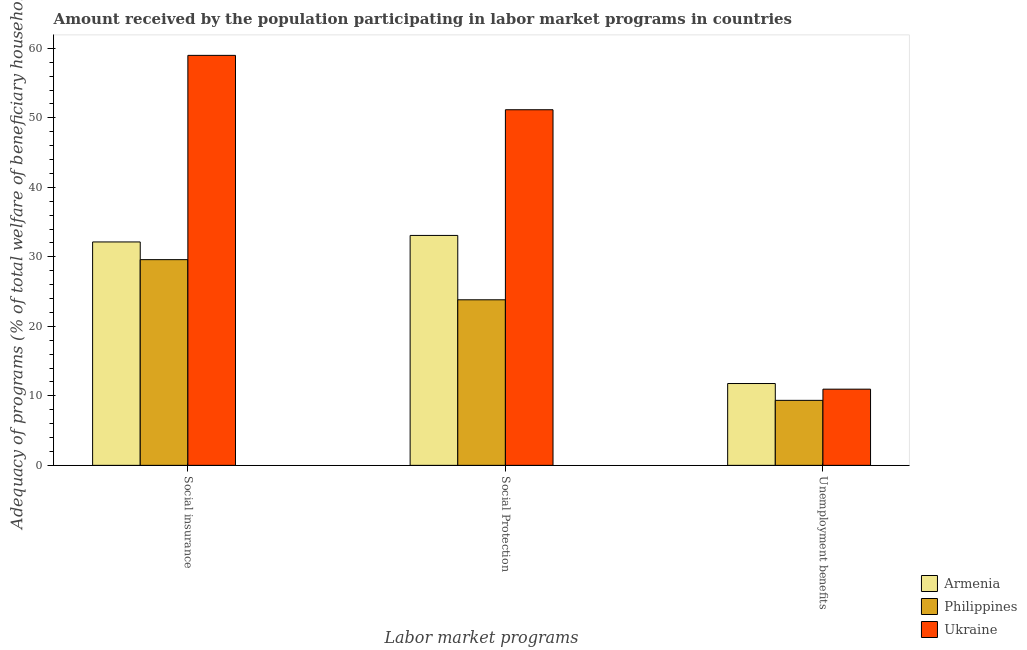How many different coloured bars are there?
Offer a terse response. 3. How many groups of bars are there?
Provide a succinct answer. 3. Are the number of bars per tick equal to the number of legend labels?
Keep it short and to the point. Yes. What is the label of the 3rd group of bars from the left?
Ensure brevity in your answer.  Unemployment benefits. What is the amount received by the population participating in unemployment benefits programs in Philippines?
Give a very brief answer. 9.35. Across all countries, what is the maximum amount received by the population participating in unemployment benefits programs?
Your answer should be very brief. 11.77. Across all countries, what is the minimum amount received by the population participating in unemployment benefits programs?
Your answer should be very brief. 9.35. In which country was the amount received by the population participating in social protection programs maximum?
Provide a succinct answer. Ukraine. In which country was the amount received by the population participating in social protection programs minimum?
Your answer should be very brief. Philippines. What is the total amount received by the population participating in social protection programs in the graph?
Provide a short and direct response. 108.08. What is the difference between the amount received by the population participating in social insurance programs in Armenia and that in Philippines?
Make the answer very short. 2.55. What is the difference between the amount received by the population participating in social protection programs in Armenia and the amount received by the population participating in unemployment benefits programs in Philippines?
Make the answer very short. 23.73. What is the average amount received by the population participating in social protection programs per country?
Provide a short and direct response. 36.03. What is the difference between the amount received by the population participating in social insurance programs and amount received by the population participating in social protection programs in Armenia?
Provide a succinct answer. -0.94. In how many countries, is the amount received by the population participating in unemployment benefits programs greater than 12 %?
Provide a short and direct response. 0. What is the ratio of the amount received by the population participating in unemployment benefits programs in Philippines to that in Armenia?
Your answer should be very brief. 0.79. Is the difference between the amount received by the population participating in social insurance programs in Philippines and Ukraine greater than the difference between the amount received by the population participating in unemployment benefits programs in Philippines and Ukraine?
Provide a succinct answer. No. What is the difference between the highest and the second highest amount received by the population participating in social protection programs?
Provide a succinct answer. 18.09. What is the difference between the highest and the lowest amount received by the population participating in social insurance programs?
Provide a succinct answer. 29.4. In how many countries, is the amount received by the population participating in social protection programs greater than the average amount received by the population participating in social protection programs taken over all countries?
Offer a very short reply. 1. Is the sum of the amount received by the population participating in unemployment benefits programs in Ukraine and Philippines greater than the maximum amount received by the population participating in social protection programs across all countries?
Provide a short and direct response. No. What does the 1st bar from the left in Social insurance represents?
Your answer should be very brief. Armenia. What does the 1st bar from the right in Unemployment benefits represents?
Offer a terse response. Ukraine. Is it the case that in every country, the sum of the amount received by the population participating in social insurance programs and amount received by the population participating in social protection programs is greater than the amount received by the population participating in unemployment benefits programs?
Make the answer very short. Yes. What is the difference between two consecutive major ticks on the Y-axis?
Provide a succinct answer. 10. Are the values on the major ticks of Y-axis written in scientific E-notation?
Make the answer very short. No. Does the graph contain any zero values?
Offer a very short reply. No. Where does the legend appear in the graph?
Make the answer very short. Bottom right. How are the legend labels stacked?
Your answer should be compact. Vertical. What is the title of the graph?
Provide a succinct answer. Amount received by the population participating in labor market programs in countries. Does "Serbia" appear as one of the legend labels in the graph?
Your answer should be very brief. No. What is the label or title of the X-axis?
Your response must be concise. Labor market programs. What is the label or title of the Y-axis?
Ensure brevity in your answer.  Adequacy of programs (% of total welfare of beneficiary households). What is the Adequacy of programs (% of total welfare of beneficiary households) of Armenia in Social insurance?
Give a very brief answer. 32.15. What is the Adequacy of programs (% of total welfare of beneficiary households) in Philippines in Social insurance?
Provide a succinct answer. 29.6. What is the Adequacy of programs (% of total welfare of beneficiary households) in Ukraine in Social insurance?
Ensure brevity in your answer.  58.99. What is the Adequacy of programs (% of total welfare of beneficiary households) in Armenia in Social Protection?
Offer a terse response. 33.08. What is the Adequacy of programs (% of total welfare of beneficiary households) of Philippines in Social Protection?
Give a very brief answer. 23.82. What is the Adequacy of programs (% of total welfare of beneficiary households) of Ukraine in Social Protection?
Your answer should be very brief. 51.17. What is the Adequacy of programs (% of total welfare of beneficiary households) in Armenia in Unemployment benefits?
Make the answer very short. 11.77. What is the Adequacy of programs (% of total welfare of beneficiary households) of Philippines in Unemployment benefits?
Ensure brevity in your answer.  9.35. What is the Adequacy of programs (% of total welfare of beneficiary households) in Ukraine in Unemployment benefits?
Your response must be concise. 10.96. Across all Labor market programs, what is the maximum Adequacy of programs (% of total welfare of beneficiary households) of Armenia?
Give a very brief answer. 33.08. Across all Labor market programs, what is the maximum Adequacy of programs (% of total welfare of beneficiary households) of Philippines?
Offer a terse response. 29.6. Across all Labor market programs, what is the maximum Adequacy of programs (% of total welfare of beneficiary households) of Ukraine?
Give a very brief answer. 58.99. Across all Labor market programs, what is the minimum Adequacy of programs (% of total welfare of beneficiary households) of Armenia?
Give a very brief answer. 11.77. Across all Labor market programs, what is the minimum Adequacy of programs (% of total welfare of beneficiary households) in Philippines?
Provide a succinct answer. 9.35. Across all Labor market programs, what is the minimum Adequacy of programs (% of total welfare of beneficiary households) in Ukraine?
Your response must be concise. 10.96. What is the total Adequacy of programs (% of total welfare of beneficiary households) of Armenia in the graph?
Offer a terse response. 77.01. What is the total Adequacy of programs (% of total welfare of beneficiary households) in Philippines in the graph?
Your answer should be compact. 62.78. What is the total Adequacy of programs (% of total welfare of beneficiary households) of Ukraine in the graph?
Your answer should be compact. 121.13. What is the difference between the Adequacy of programs (% of total welfare of beneficiary households) of Armenia in Social insurance and that in Social Protection?
Ensure brevity in your answer.  -0.94. What is the difference between the Adequacy of programs (% of total welfare of beneficiary households) in Philippines in Social insurance and that in Social Protection?
Ensure brevity in your answer.  5.78. What is the difference between the Adequacy of programs (% of total welfare of beneficiary households) in Ukraine in Social insurance and that in Social Protection?
Provide a short and direct response. 7.82. What is the difference between the Adequacy of programs (% of total welfare of beneficiary households) in Armenia in Social insurance and that in Unemployment benefits?
Keep it short and to the point. 20.37. What is the difference between the Adequacy of programs (% of total welfare of beneficiary households) in Philippines in Social insurance and that in Unemployment benefits?
Offer a very short reply. 20.25. What is the difference between the Adequacy of programs (% of total welfare of beneficiary households) in Ukraine in Social insurance and that in Unemployment benefits?
Keep it short and to the point. 48.03. What is the difference between the Adequacy of programs (% of total welfare of beneficiary households) in Armenia in Social Protection and that in Unemployment benefits?
Make the answer very short. 21.31. What is the difference between the Adequacy of programs (% of total welfare of beneficiary households) in Philippines in Social Protection and that in Unemployment benefits?
Make the answer very short. 14.47. What is the difference between the Adequacy of programs (% of total welfare of beneficiary households) of Ukraine in Social Protection and that in Unemployment benefits?
Your response must be concise. 40.21. What is the difference between the Adequacy of programs (% of total welfare of beneficiary households) of Armenia in Social insurance and the Adequacy of programs (% of total welfare of beneficiary households) of Philippines in Social Protection?
Your answer should be very brief. 8.32. What is the difference between the Adequacy of programs (% of total welfare of beneficiary households) of Armenia in Social insurance and the Adequacy of programs (% of total welfare of beneficiary households) of Ukraine in Social Protection?
Your answer should be compact. -19.02. What is the difference between the Adequacy of programs (% of total welfare of beneficiary households) in Philippines in Social insurance and the Adequacy of programs (% of total welfare of beneficiary households) in Ukraine in Social Protection?
Ensure brevity in your answer.  -21.57. What is the difference between the Adequacy of programs (% of total welfare of beneficiary households) of Armenia in Social insurance and the Adequacy of programs (% of total welfare of beneficiary households) of Philippines in Unemployment benefits?
Ensure brevity in your answer.  22.79. What is the difference between the Adequacy of programs (% of total welfare of beneficiary households) of Armenia in Social insurance and the Adequacy of programs (% of total welfare of beneficiary households) of Ukraine in Unemployment benefits?
Provide a succinct answer. 21.19. What is the difference between the Adequacy of programs (% of total welfare of beneficiary households) of Philippines in Social insurance and the Adequacy of programs (% of total welfare of beneficiary households) of Ukraine in Unemployment benefits?
Offer a terse response. 18.64. What is the difference between the Adequacy of programs (% of total welfare of beneficiary households) in Armenia in Social Protection and the Adequacy of programs (% of total welfare of beneficiary households) in Philippines in Unemployment benefits?
Offer a terse response. 23.73. What is the difference between the Adequacy of programs (% of total welfare of beneficiary households) of Armenia in Social Protection and the Adequacy of programs (% of total welfare of beneficiary households) of Ukraine in Unemployment benefits?
Make the answer very short. 22.12. What is the difference between the Adequacy of programs (% of total welfare of beneficiary households) of Philippines in Social Protection and the Adequacy of programs (% of total welfare of beneficiary households) of Ukraine in Unemployment benefits?
Your answer should be compact. 12.86. What is the average Adequacy of programs (% of total welfare of beneficiary households) of Armenia per Labor market programs?
Give a very brief answer. 25.67. What is the average Adequacy of programs (% of total welfare of beneficiary households) in Philippines per Labor market programs?
Ensure brevity in your answer.  20.93. What is the average Adequacy of programs (% of total welfare of beneficiary households) of Ukraine per Labor market programs?
Offer a very short reply. 40.38. What is the difference between the Adequacy of programs (% of total welfare of beneficiary households) in Armenia and Adequacy of programs (% of total welfare of beneficiary households) in Philippines in Social insurance?
Make the answer very short. 2.55. What is the difference between the Adequacy of programs (% of total welfare of beneficiary households) of Armenia and Adequacy of programs (% of total welfare of beneficiary households) of Ukraine in Social insurance?
Your answer should be compact. -26.85. What is the difference between the Adequacy of programs (% of total welfare of beneficiary households) in Philippines and Adequacy of programs (% of total welfare of beneficiary households) in Ukraine in Social insurance?
Your answer should be very brief. -29.4. What is the difference between the Adequacy of programs (% of total welfare of beneficiary households) in Armenia and Adequacy of programs (% of total welfare of beneficiary households) in Philippines in Social Protection?
Make the answer very short. 9.26. What is the difference between the Adequacy of programs (% of total welfare of beneficiary households) of Armenia and Adequacy of programs (% of total welfare of beneficiary households) of Ukraine in Social Protection?
Your answer should be very brief. -18.09. What is the difference between the Adequacy of programs (% of total welfare of beneficiary households) of Philippines and Adequacy of programs (% of total welfare of beneficiary households) of Ukraine in Social Protection?
Provide a succinct answer. -27.35. What is the difference between the Adequacy of programs (% of total welfare of beneficiary households) of Armenia and Adequacy of programs (% of total welfare of beneficiary households) of Philippines in Unemployment benefits?
Offer a terse response. 2.42. What is the difference between the Adequacy of programs (% of total welfare of beneficiary households) in Armenia and Adequacy of programs (% of total welfare of beneficiary households) in Ukraine in Unemployment benefits?
Offer a very short reply. 0.81. What is the difference between the Adequacy of programs (% of total welfare of beneficiary households) of Philippines and Adequacy of programs (% of total welfare of beneficiary households) of Ukraine in Unemployment benefits?
Offer a very short reply. -1.61. What is the ratio of the Adequacy of programs (% of total welfare of beneficiary households) of Armenia in Social insurance to that in Social Protection?
Your answer should be compact. 0.97. What is the ratio of the Adequacy of programs (% of total welfare of beneficiary households) of Philippines in Social insurance to that in Social Protection?
Keep it short and to the point. 1.24. What is the ratio of the Adequacy of programs (% of total welfare of beneficiary households) in Ukraine in Social insurance to that in Social Protection?
Give a very brief answer. 1.15. What is the ratio of the Adequacy of programs (% of total welfare of beneficiary households) of Armenia in Social insurance to that in Unemployment benefits?
Give a very brief answer. 2.73. What is the ratio of the Adequacy of programs (% of total welfare of beneficiary households) of Philippines in Social insurance to that in Unemployment benefits?
Provide a short and direct response. 3.16. What is the ratio of the Adequacy of programs (% of total welfare of beneficiary households) in Ukraine in Social insurance to that in Unemployment benefits?
Provide a succinct answer. 5.38. What is the ratio of the Adequacy of programs (% of total welfare of beneficiary households) of Armenia in Social Protection to that in Unemployment benefits?
Your answer should be compact. 2.81. What is the ratio of the Adequacy of programs (% of total welfare of beneficiary households) of Philippines in Social Protection to that in Unemployment benefits?
Ensure brevity in your answer.  2.55. What is the ratio of the Adequacy of programs (% of total welfare of beneficiary households) of Ukraine in Social Protection to that in Unemployment benefits?
Offer a very short reply. 4.67. What is the difference between the highest and the second highest Adequacy of programs (% of total welfare of beneficiary households) in Armenia?
Provide a short and direct response. 0.94. What is the difference between the highest and the second highest Adequacy of programs (% of total welfare of beneficiary households) of Philippines?
Your response must be concise. 5.78. What is the difference between the highest and the second highest Adequacy of programs (% of total welfare of beneficiary households) in Ukraine?
Offer a terse response. 7.82. What is the difference between the highest and the lowest Adequacy of programs (% of total welfare of beneficiary households) of Armenia?
Ensure brevity in your answer.  21.31. What is the difference between the highest and the lowest Adequacy of programs (% of total welfare of beneficiary households) in Philippines?
Ensure brevity in your answer.  20.25. What is the difference between the highest and the lowest Adequacy of programs (% of total welfare of beneficiary households) of Ukraine?
Provide a short and direct response. 48.03. 